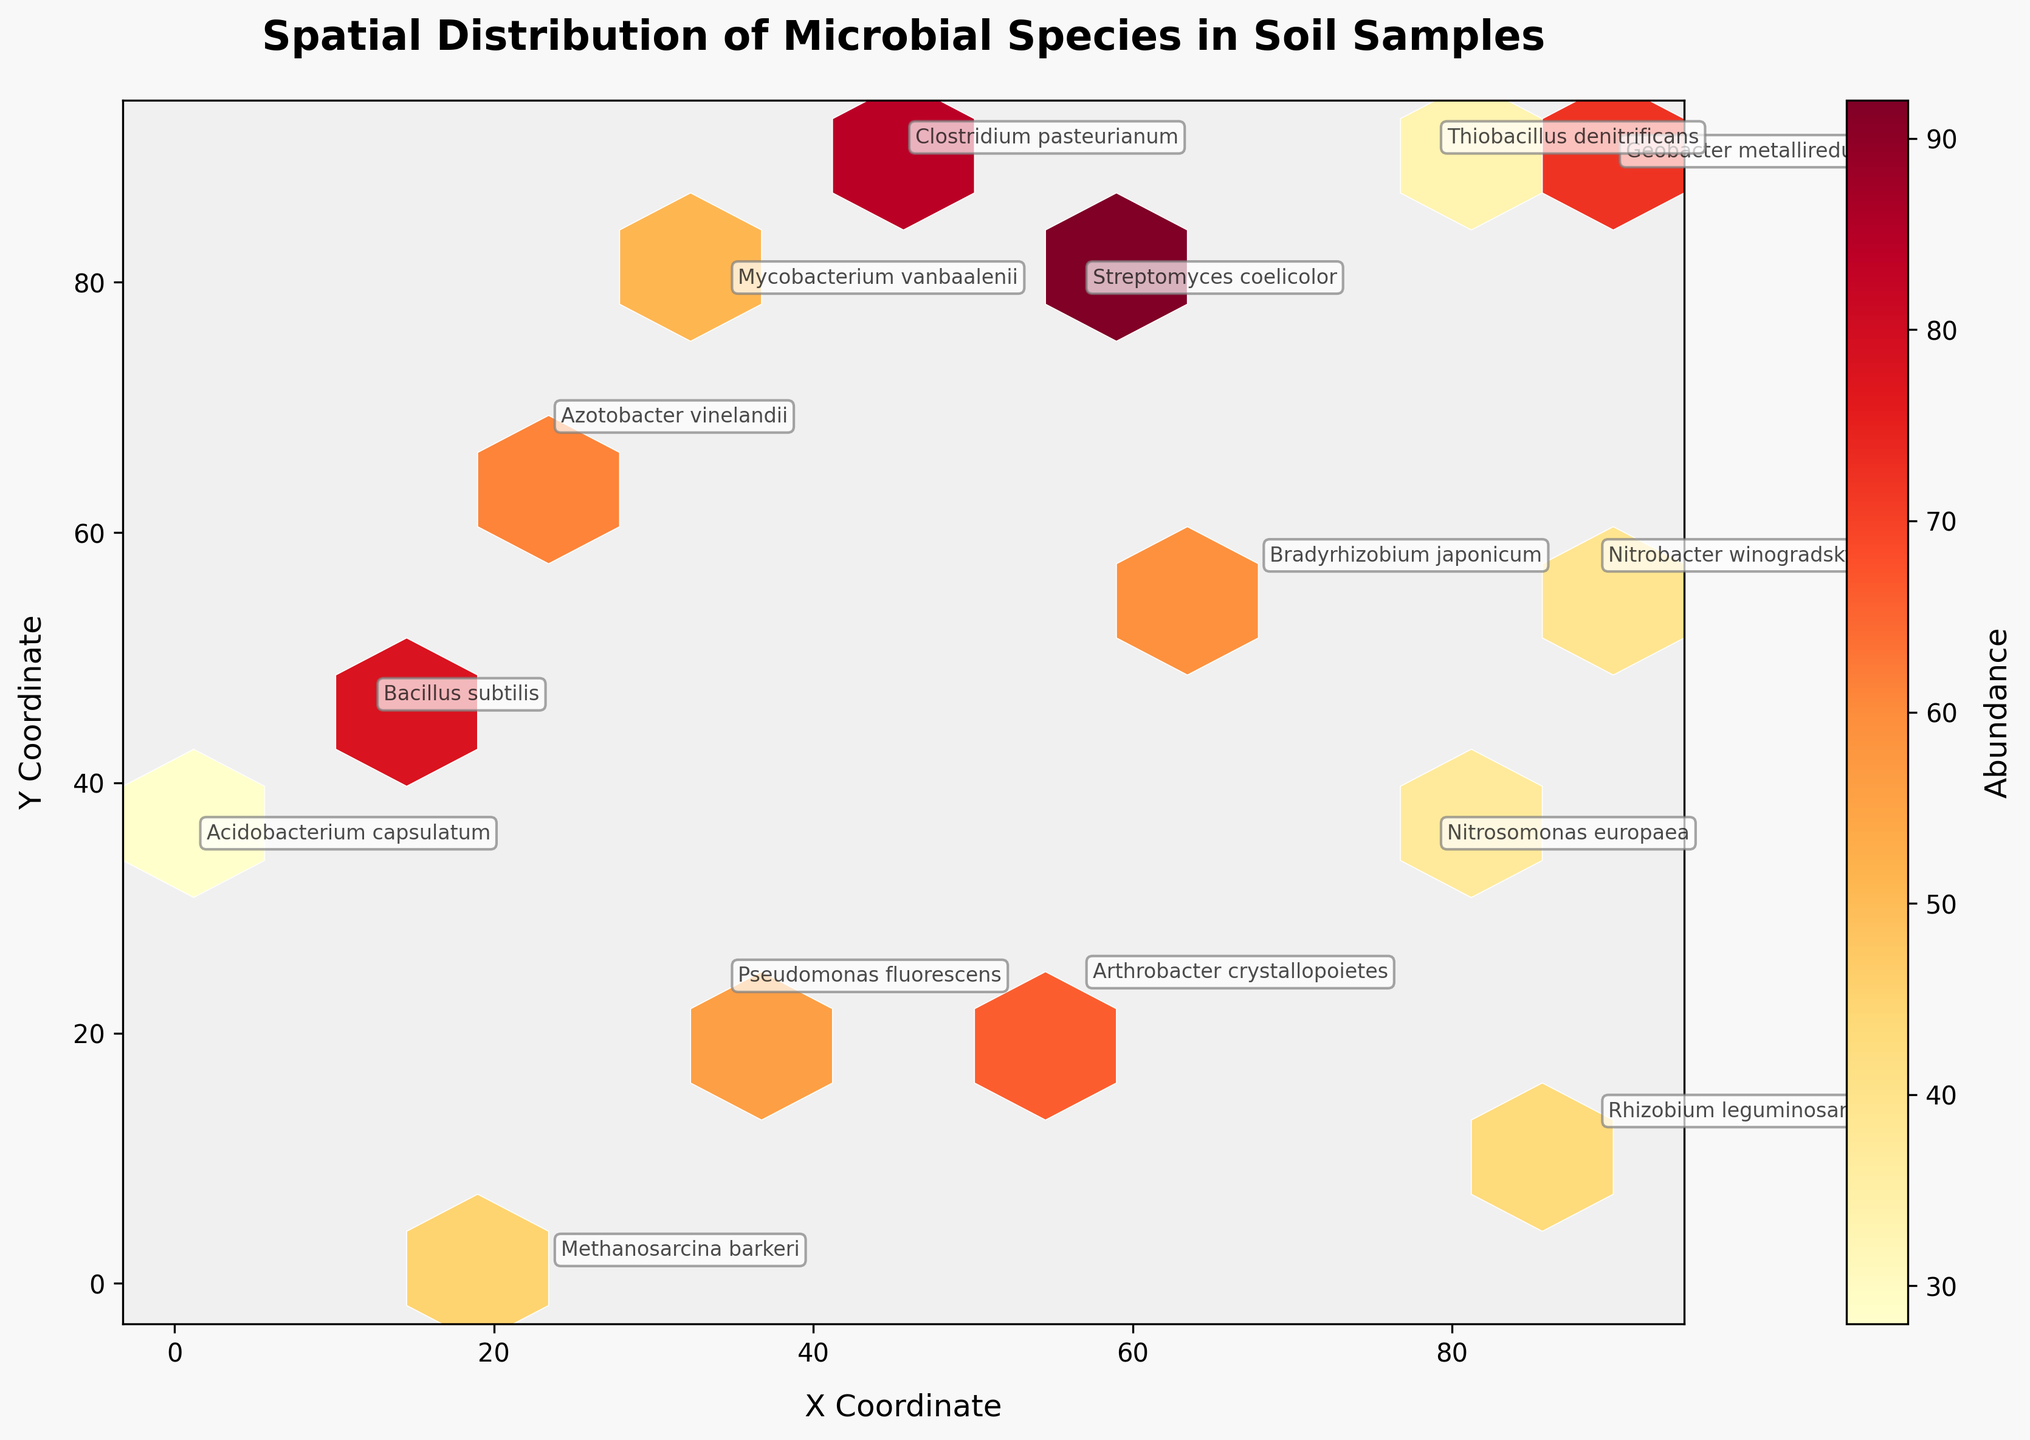What's the title of the figure? The title is typically located at the top of the plot. Reading from the top, it is "Spatial Distribution of Microbial Species in Soil Samples".
Answer: Spatial Distribution of Microbial Species in Soil Samples What are the labels of the x and y axes? The x-axis label is at the bottom and reads "X Coordinate". The y-axis label on the left side reads "Y Coordinate".
Answer: X Coordinate, Y Coordinate What does the color bar represent? The color bar, which is usually found to the right of the plot, indicates the "Abundance" of microbial species. This is also labeled next to the bar.
Answer: Abundance Which microbial species has the highest abundance? To find this, look for the species name annotation with the highest color intensity in the hexagonal bins. This would be Streptomyces coelicolor with an abundance of 92.
Answer: Streptomyces coelicolor How does the abundance of Rhizobium leguminosarum compare to Nitrobacter winogradskyi? Locate the annotations for both species and refer to their respective colors in the hexbin bins. Rhizobium leguminosarum has an abundance of 43, while Nitrobacter winogradskyi has an abundance of 39. Thus, Rhizobium leguminosarum has a slightly higher abundance than Nitrobacter winogradskyi.
Answer: Rhizobium leguminosarum > Nitrobacter winogradskyi Which abundance values are represented by the lightest and darkest shades of the bins? The color gradient on the bins correlates to the color bar levels. The lightest shades represent the lowest abundance, near 28 (for Acidobacterium capsulatum). The darkest shades will be nearer to 92 (for Streptomyces coelicolor).
Answer: Lightest: 28, Darkest: 92 What species are located around the coordinates (34.5, 23.1)? Checking this coordinate, we find it matches the annotated position of Pseudomonas fluorescens.
Answer: Pseudomonas fluorescens What does a hexagon with a low abundance indicate in the plot? A hexagon with a low abundance suggests that the microbial species in that specific spatial location is not very prevalent, represented by a lighter color.
Answer: Low prevalence of microbes Comparing the x-coordinates, which species is the farthest to the left? Locate the species with the lowest x-coordinate value. Acidobacterium capsulatum is positioned at x = 1.2, the smallest x-coordinate in the dataset.
Answer: Acidobacterium capsulatum How uniform is the distribution of the species abundance across the spatial coordinates? By observing the color distribution of the hexagonal bins, which ranges from light to dark, one can see if the abundance is concentrated in certain areas or uniformly spread out. The distribution seems non-uniform with specific areas showing higher density.
Answer: Non-uniform distribution 